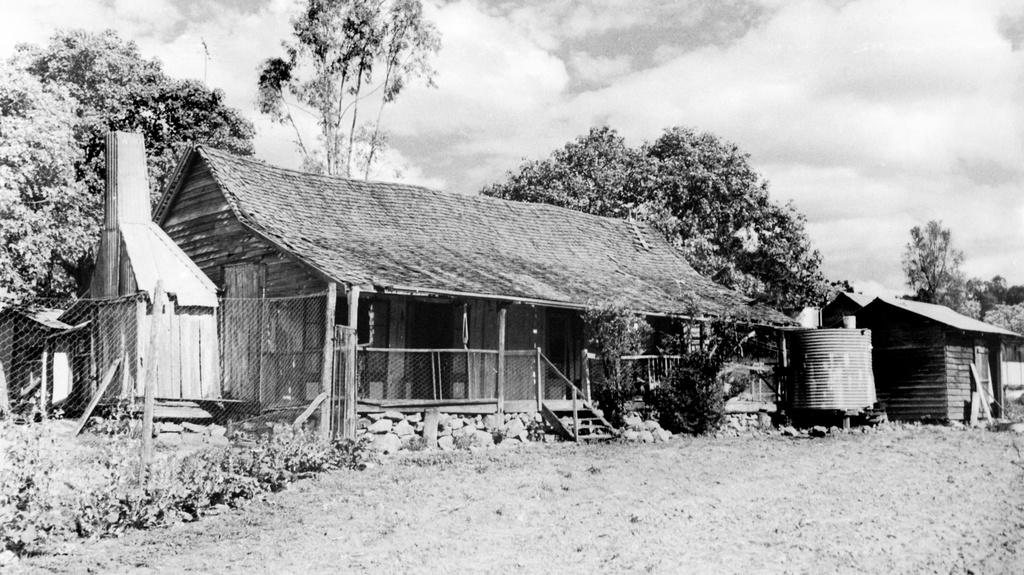What is the color scheme of the image? The image is black and white. What structures can be seen in the foreground of the image? There are huts, a tank, trees, stones, plants, and fencing in the foreground of the image. What is visible in the background of the image? The sky is visible in the image. Can you describe the weather conditions in the image? There are clouds visible in the image, suggesting a partly cloudy day. What type of glove is being used by the prisoner in the image? There is no prisoner or glove present in the image. What type of pleasure can be seen being experienced by the people in the image? There is no indication of pleasure being experienced by anyone in the image. 